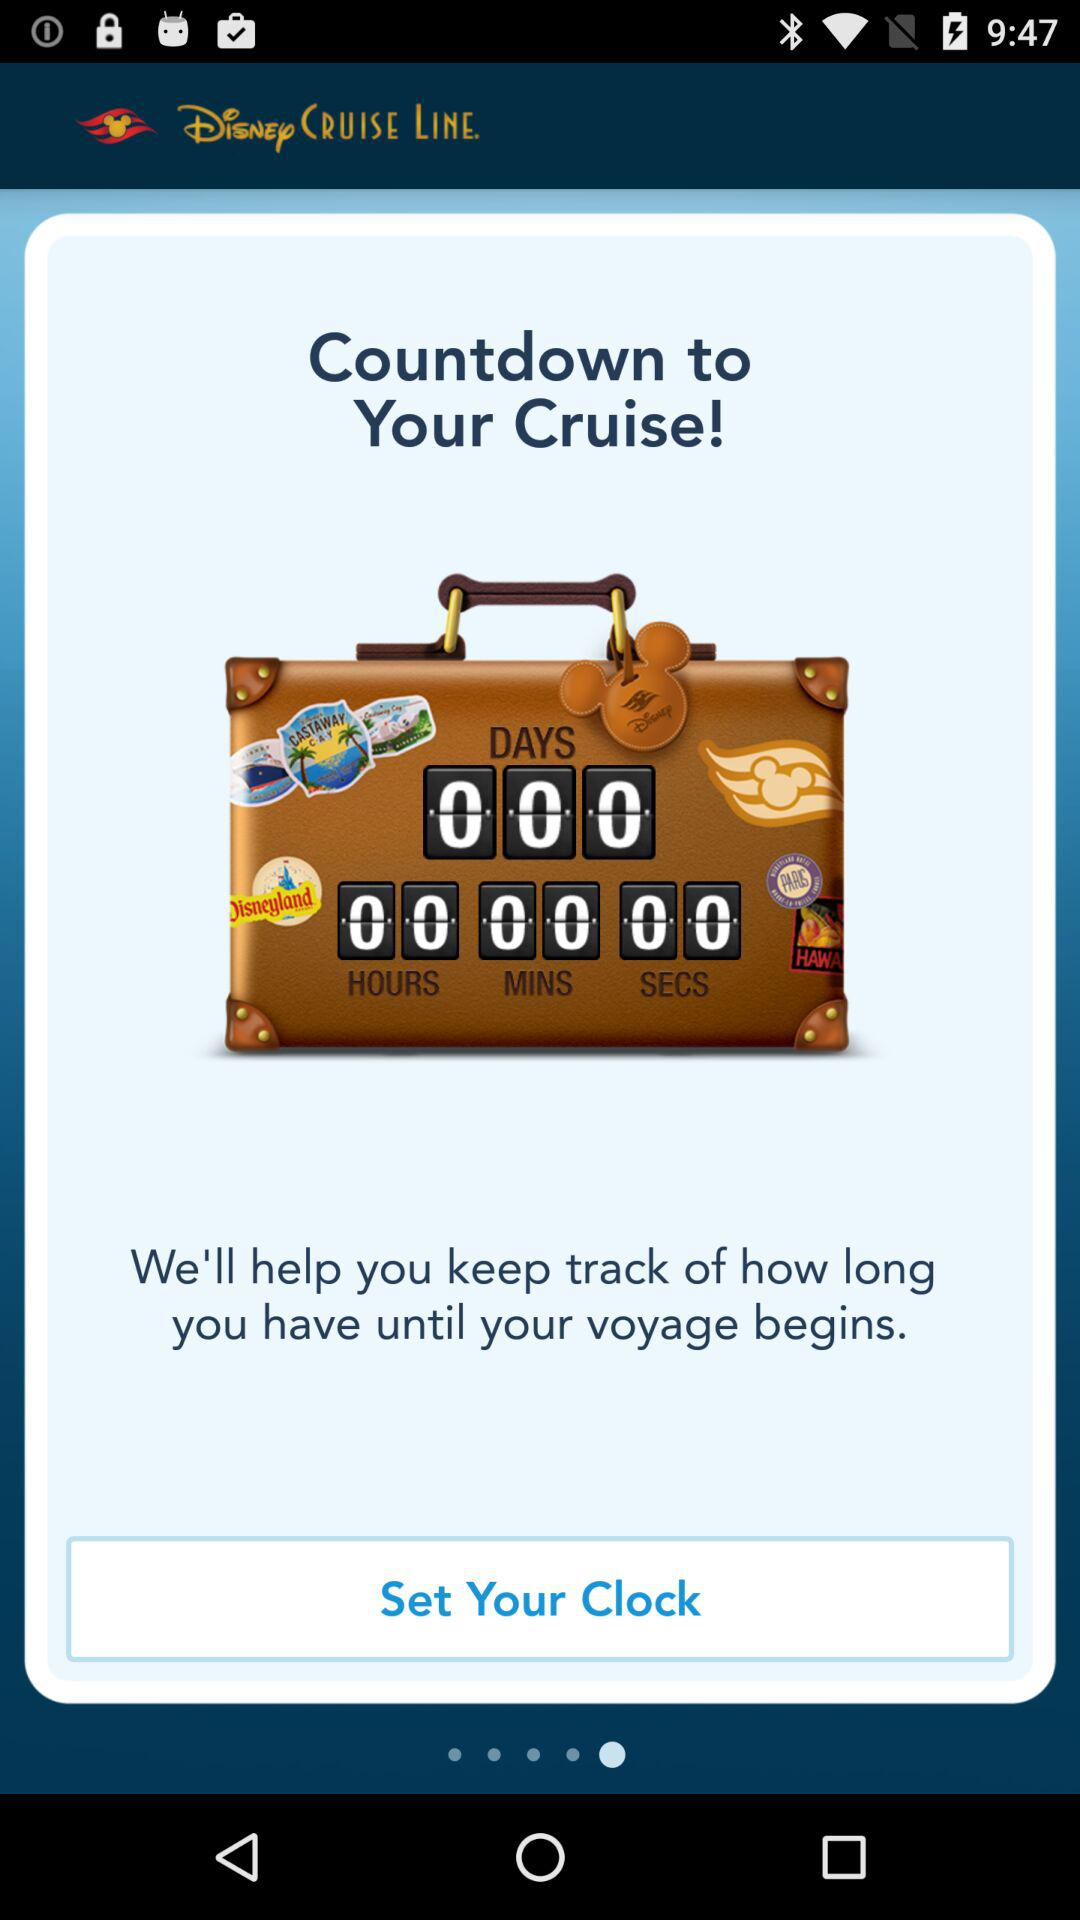What is the name of the application? The name of the application is "Disney CRUISE LINE". 